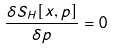<formula> <loc_0><loc_0><loc_500><loc_500>\frac { \delta S _ { H } [ x , p ] } { \delta p } = 0</formula> 